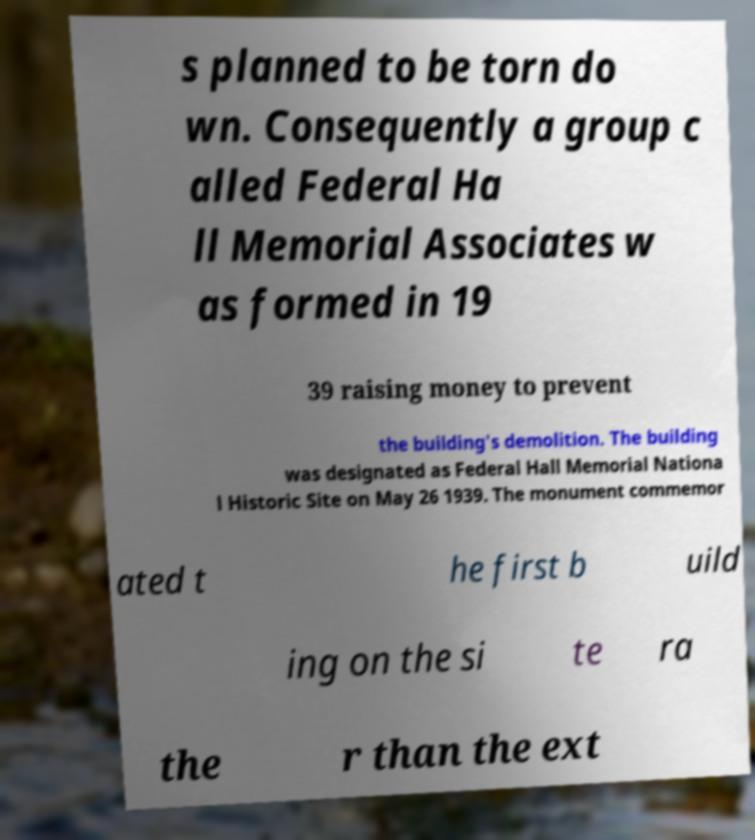Could you extract and type out the text from this image? s planned to be torn do wn. Consequently a group c alled Federal Ha ll Memorial Associates w as formed in 19 39 raising money to prevent the building's demolition. The building was designated as Federal Hall Memorial Nationa l Historic Site on May 26 1939. The monument commemor ated t he first b uild ing on the si te ra the r than the ext 